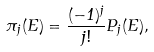<formula> <loc_0><loc_0><loc_500><loc_500>\pi _ { j } ( E ) = \frac { ( - 1 ) ^ { j } } { j ! } P _ { j } ( E ) ,</formula> 